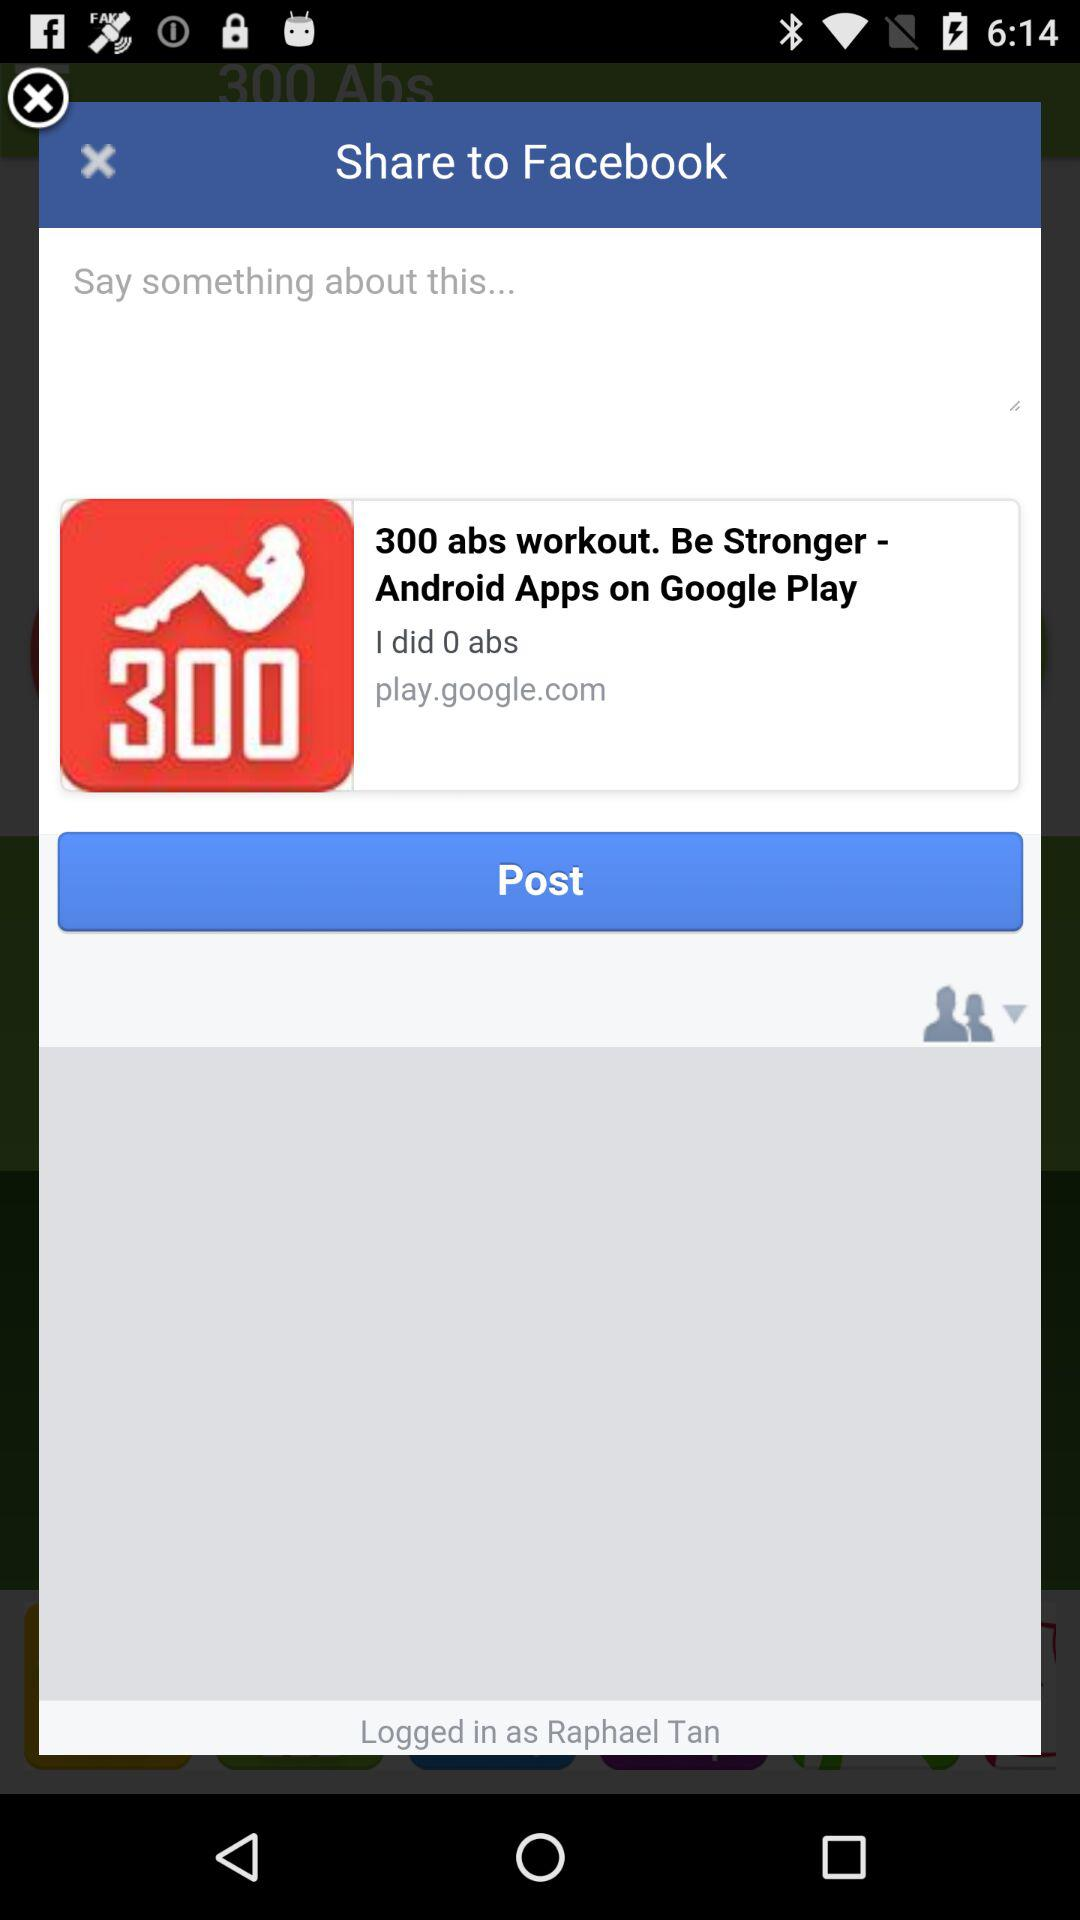How many people are logged into this account?
Answer the question using a single word or phrase. 1 